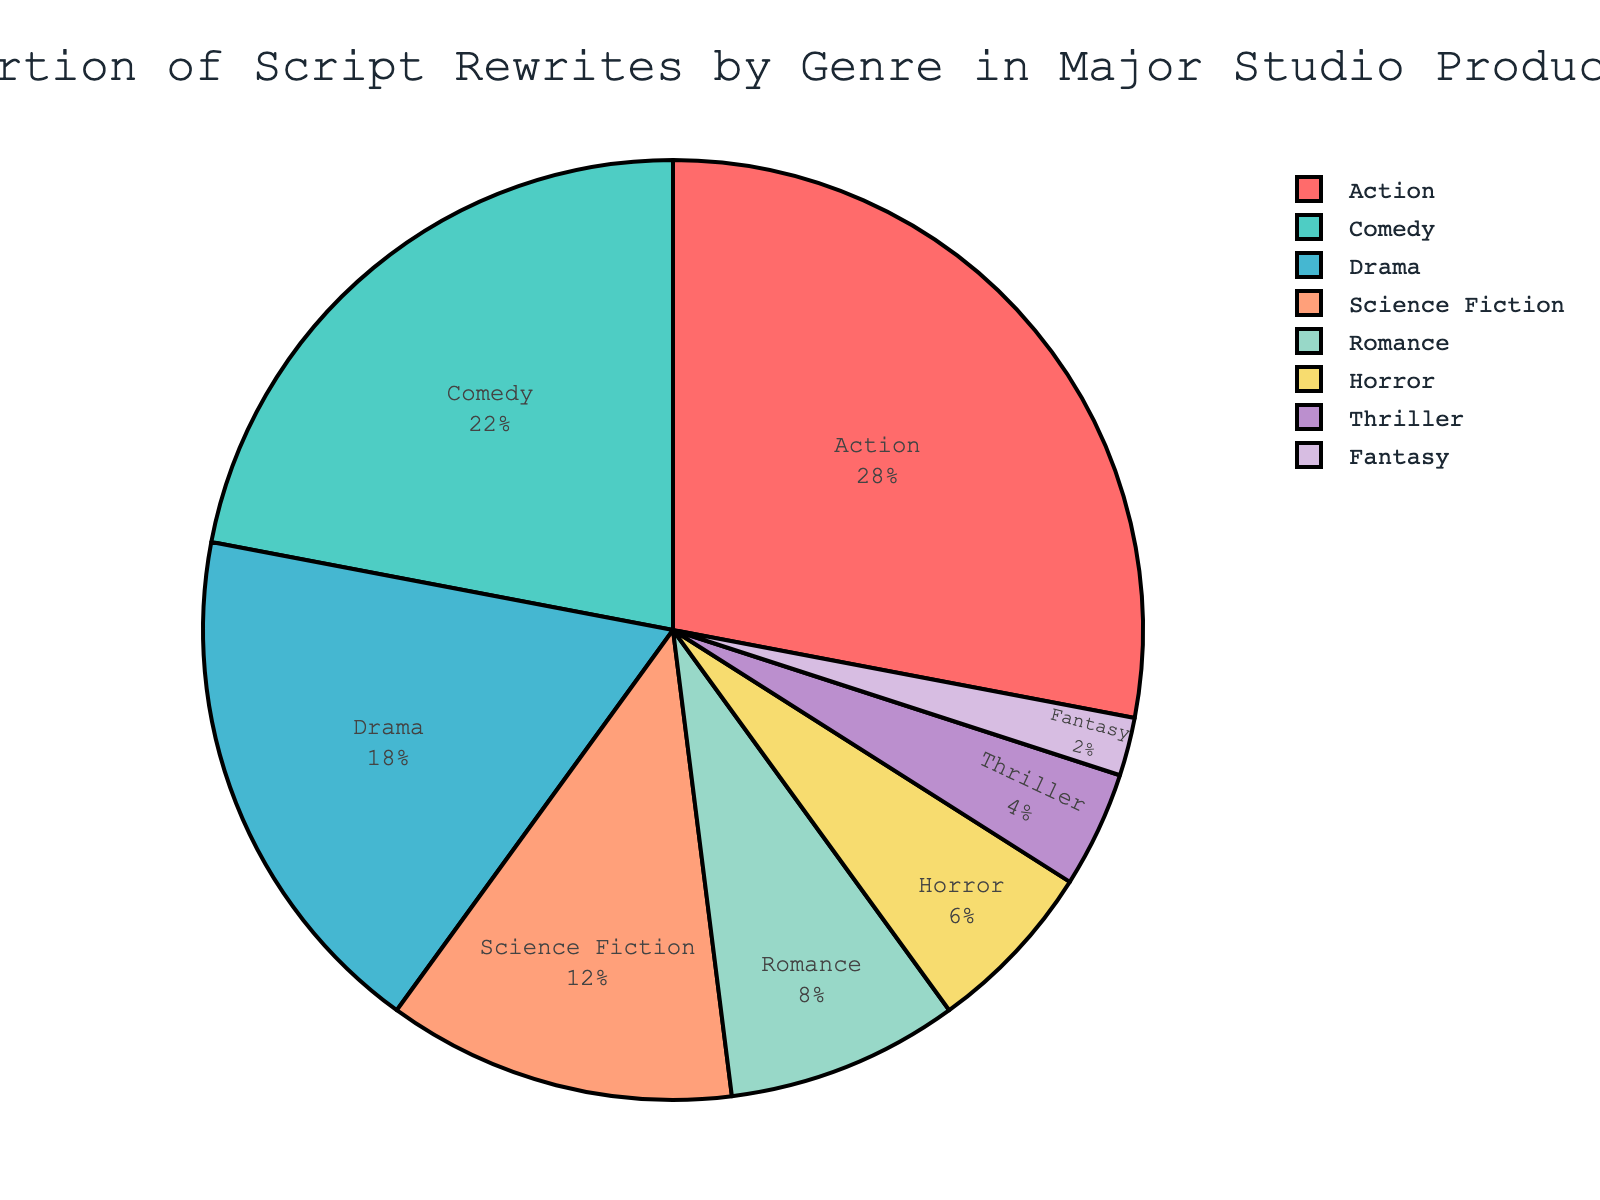What genre occupies the largest proportion in the pie chart? The sector with the largest proportion visually represents Action, as it is the biggest slice of the pie.
Answer: Action Which two genres have the smallest proportions? The two smallest sectors of the pie, visually, are Thriller and Fantasy, as they have the smallest slices.
Answer: Thriller and Fantasy What is the combined percentage of Comedy and Drama in script rewrites? The percentage for Comedy is 22% and Drama is 18%. Summing them up: 22% + 18% = 40%
Answer: 40% Is the proportion of Science Fiction greater than that of Romance? Yes. The Science Fiction sector is significantly larger than the Romance sector. Science Fiction is 12% and Romance is 8%.
Answer: Yes How much more significant is the proportion of Horror compared to Thriller? The proportion for Horror is 6% and for Thriller is 4%. The difference is calculated as 6% - 4% = 2%.
Answer: 2% Which genre has 22% of the script rewrites? The sector labeled 'Comedy' shows 22%, which confirms that Comedy has this proportion.
Answer: Comedy Is Science Fiction’s proportion exactly half that of Action’s? Action is 28% and Science Fiction is 12%. Half of Action’s proportion would be 28% / 2 = 14%. Since 12% is not equal to 14%, Science Fiction is not exactly half of Action.
Answer: No What is the visual color representing Drama in the pie chart? Drama is colored light blue, one of the distinct colors in the chart used for the various genres.
Answer: Light blue Compare the total proportion of genres Action, Comedy, and Drama against the remaining genres. The sum for Action, Comedy, and Drama is 28% + 22% + 18% = 68%. The remaining genres sum up as 100% - 68% = 32%. Therefore, Action, Comedy, and Drama have a larger combined proportion than the remaining genres.
Answer: Action, Comedy, and Drama have a larger proportion What is the difference in percentage points between Comedy and Horror? Comedy is 22% and Horror is 6%. The difference is calculated as 22% - 6% = 16%.
Answer: 16% 